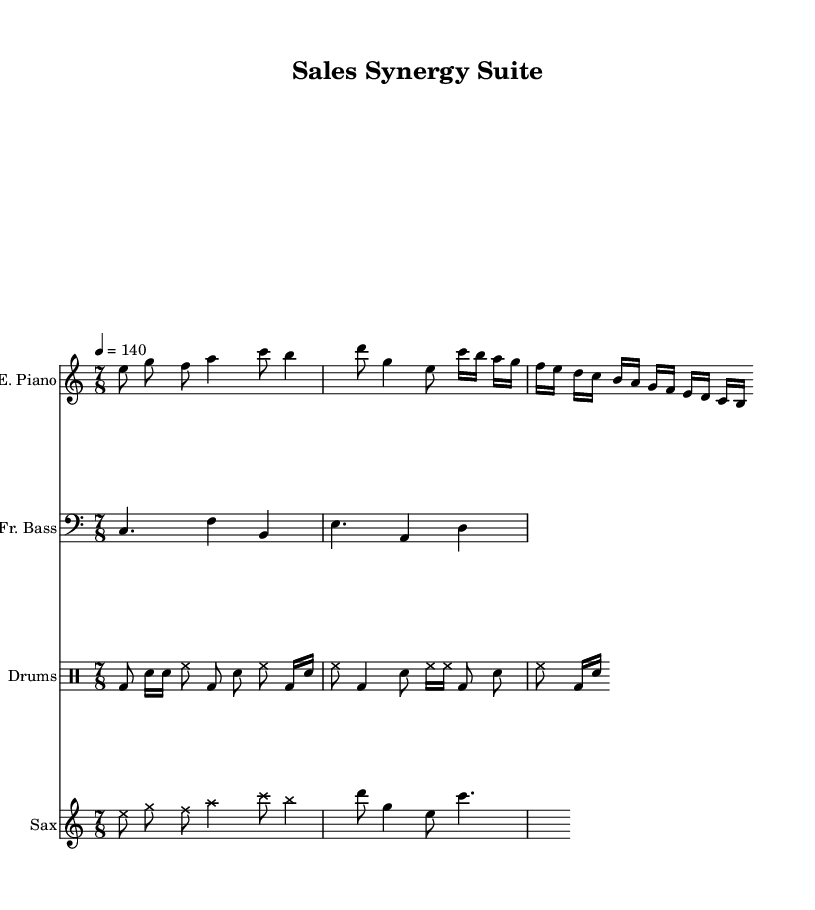What is the time signature of this music? The time signature is found at the beginning of the score and is noted as 7/8, indicating that there are 7 eighth-note beats in each measure.
Answer: 7/8 What is the tempo marking of this piece? The tempo is given at the beginning of the score with a marking of "4 = 140," meaning that there are 140 beats per minute, with each beat being a quarter note.
Answer: 140 How many instruments are featured in the score? By counting the distinct staves and instrument names in the score, there are four instruments: Electric Piano, Fretless Bass, Drums, and Saxophone.
Answer: Four What is the clef used for the Electric Piano? The clef for the Electric Piano is indicated in the music notation as a treble clef, which is represented by the symbol at the beginning of the staff for that instrument.
Answer: Treble Which instrument has a cross note head style in the score? The score specifies that the Saxophone part has a section where the notehead style is overridden to cross, indicating that it uses a unique visual representation for certain notes.
Answer: Saxophone How is the rhythmic complexity represented in the drum part? The drum part features a variety of note values, including eighth notes and sixteenth notes, which combined across several measures creates a polyrhythmic texture typical in avant-garde jazz fusion.
Answer: Rhythmic complexity What stylistic feature distinguishes this avant-garde composition? The presence of unconventional time signatures and improvisatory techniques, along with diverse instrumentation, reflects the avant-garde style, which often challenges traditional norms in music composition.
Answer: Unconventional time signatures 